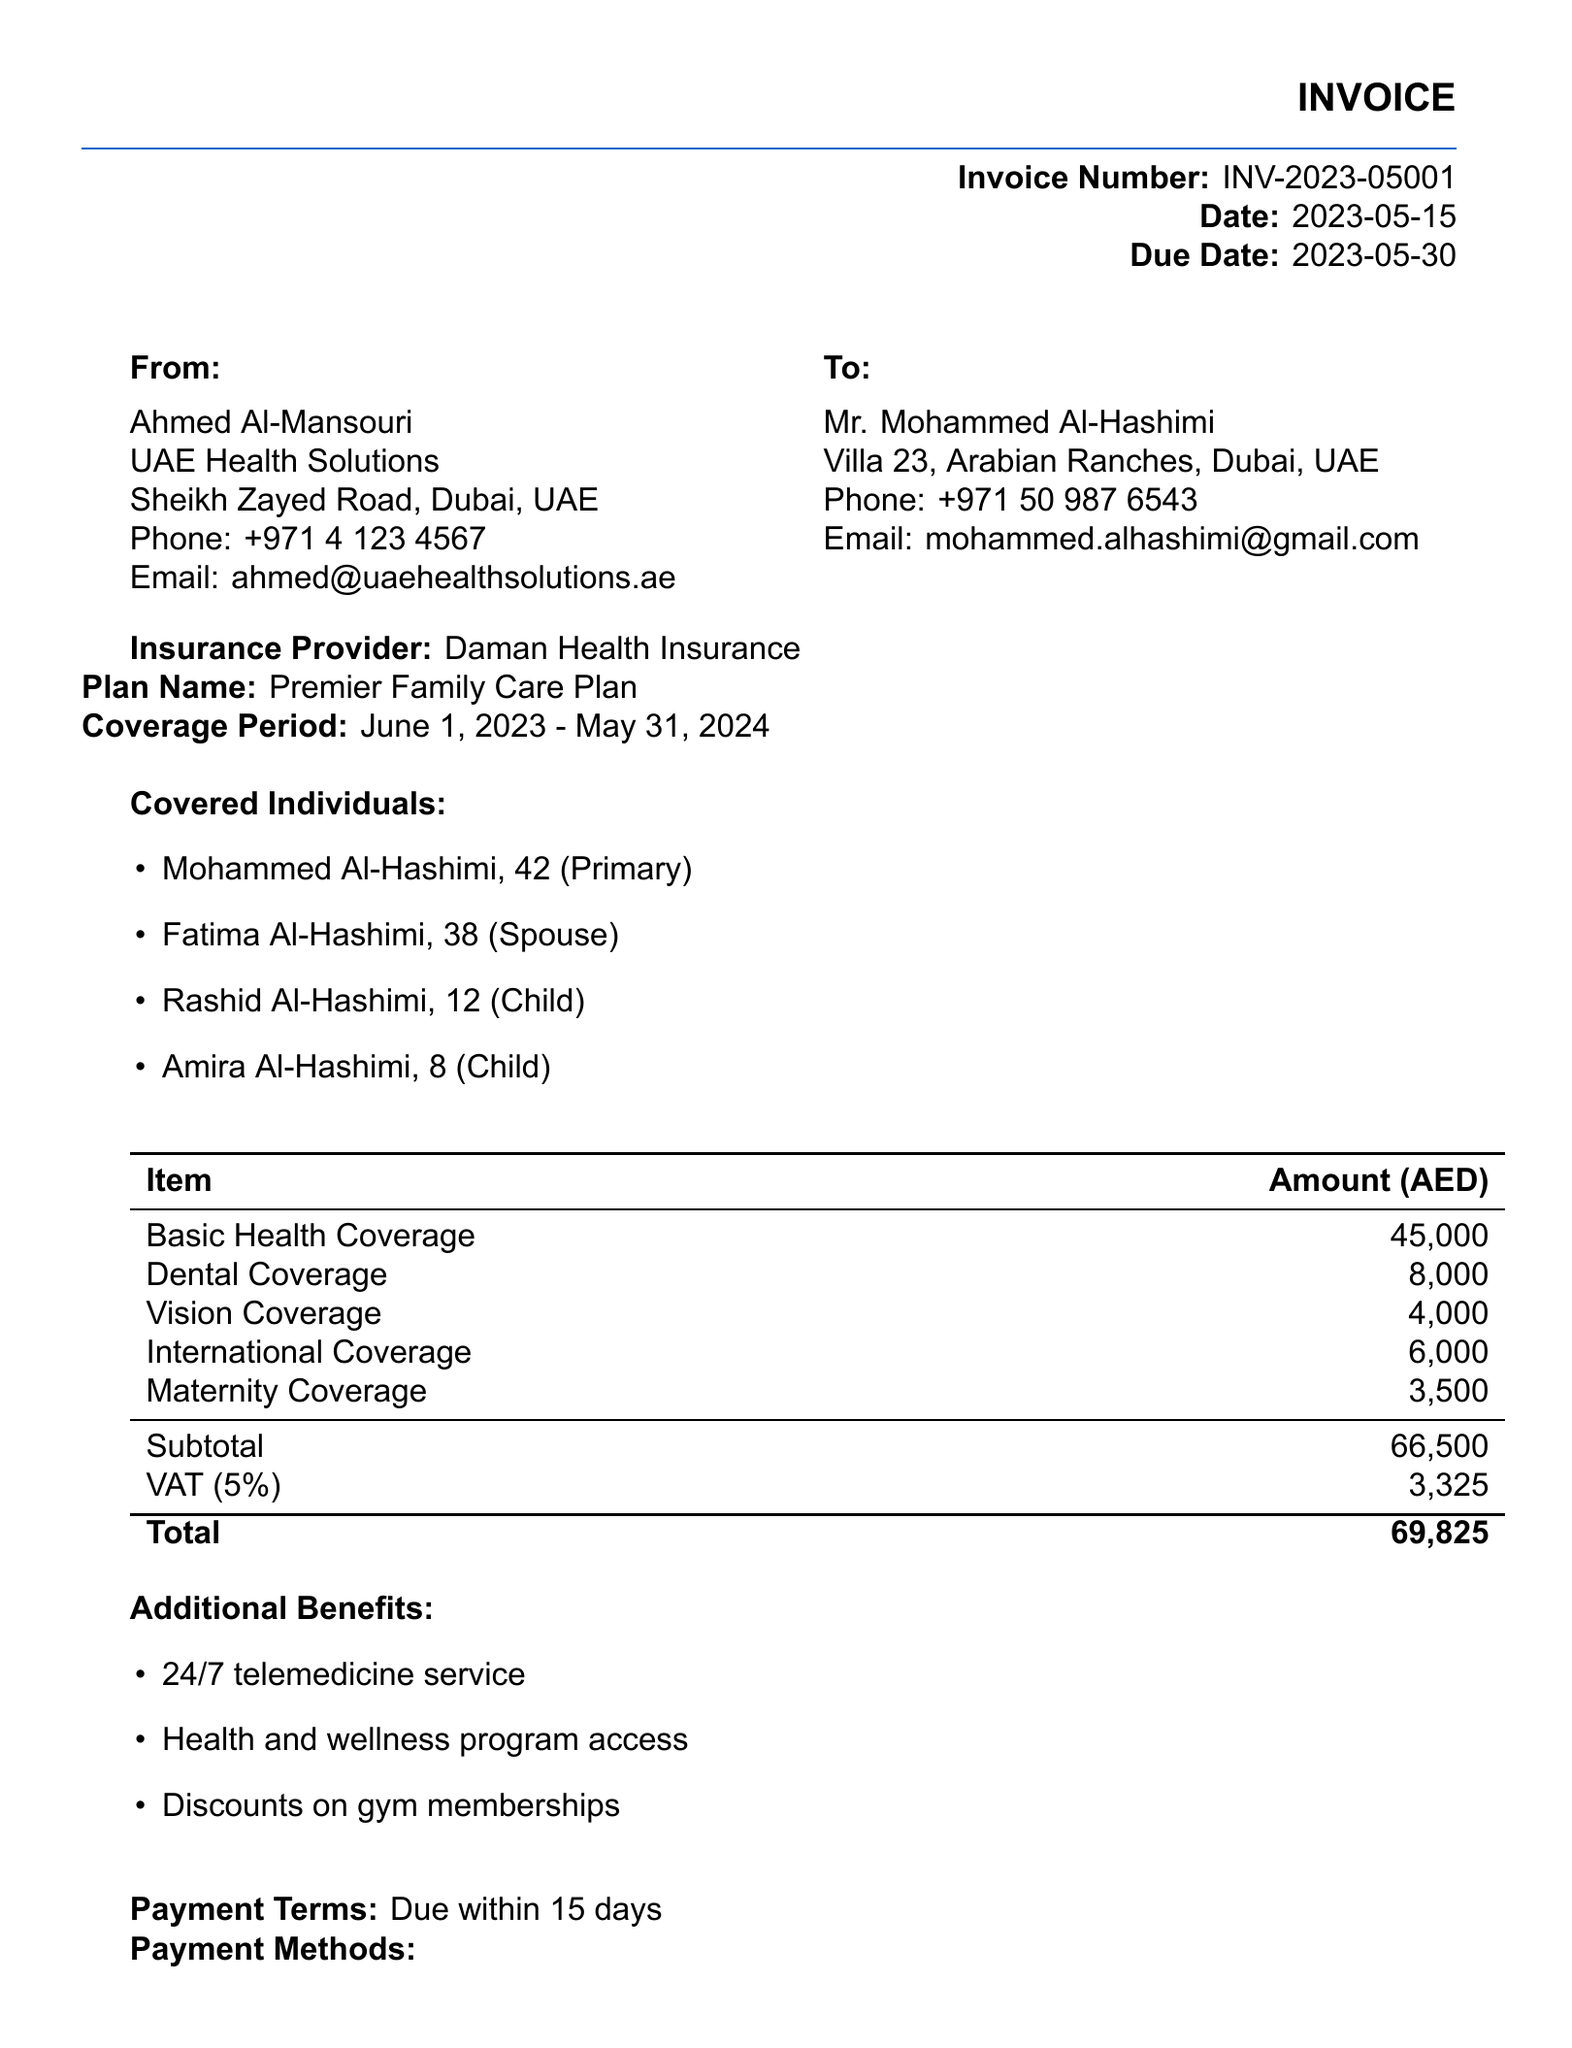What is the invoice number? The invoice number is listed in the document header for easy reference.
Answer: INV-2023-05001 What is the total amount due? The total amount due is usually highlighted at the end of the invoice, summarizing all charges.
Answer: 69,825 Who is the insurance provider? The insurance provider is mentioned in the main body of the invoice, indicating who is responsible for the coverage.
Answer: Daman Health Insurance What is the coverage period? The coverage period specifies the time frame for which the health insurance plan is valid.
Answer: June 1, 2023 - May 31, 2024 How many individuals are covered under the plan? The number of covered individuals is detailed under the 'Covered Individuals' section of the invoice.
Answer: Four What is the subtotal before VAT? The subtotal is the sum of all charges before taxes are applied, clearly shown in the itemization.
Answer: 66,500 What is one additional benefit included in the plan? Additional benefits provide extra value beyond standard coverage and are listed prominently.
Answer: 24/7 telemedicine service What is the payment due date? The payment due date indicates when the total amount must be paid and is specified in the invoice.
Answer: 2023-05-30 What method of payment is accepted? Payment methods are provided to explain how the client can settle the invoice.
Answer: Bank transfer to IBAN: AE070331234567890123456 